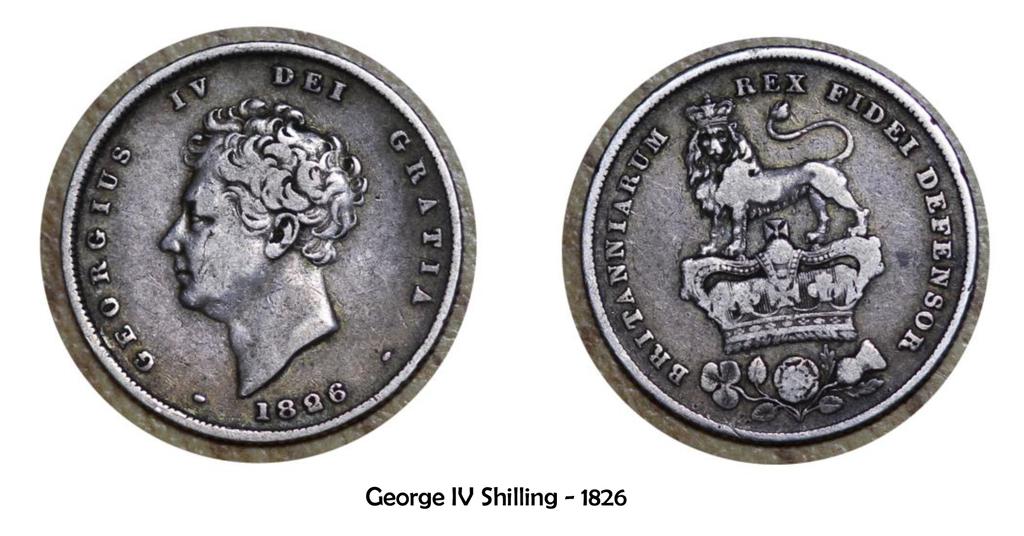What year is on the coin?
Provide a succinct answer. 1826. Who is the coin named after?
Provide a succinct answer. George iv. 